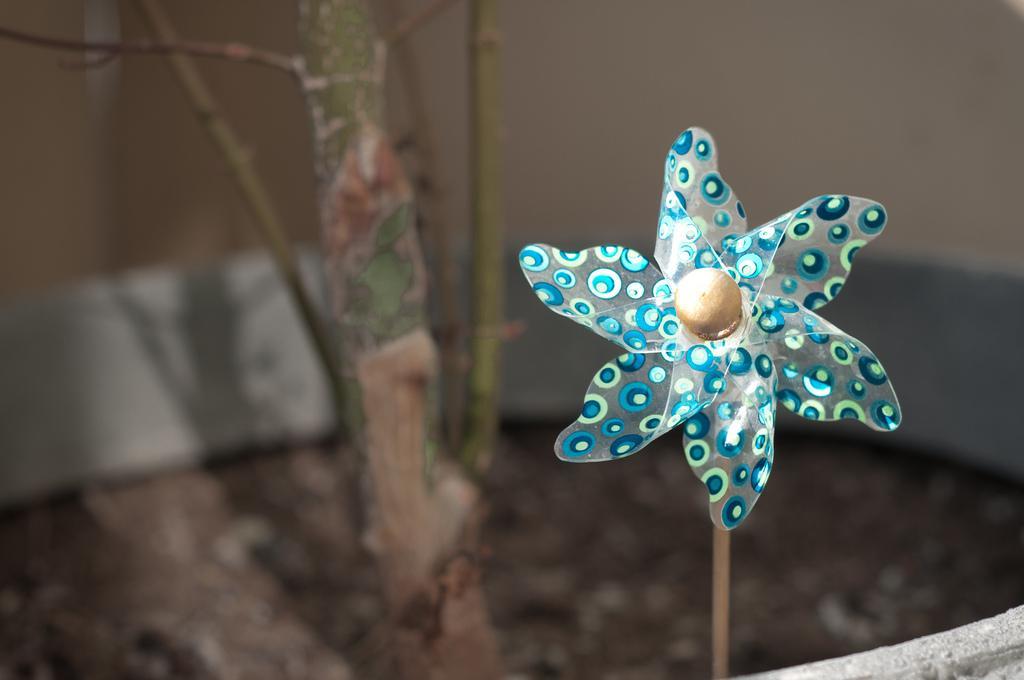Please provide a concise description of this image. In this image I can see a flower made up of paper. I can also paintings on it. 